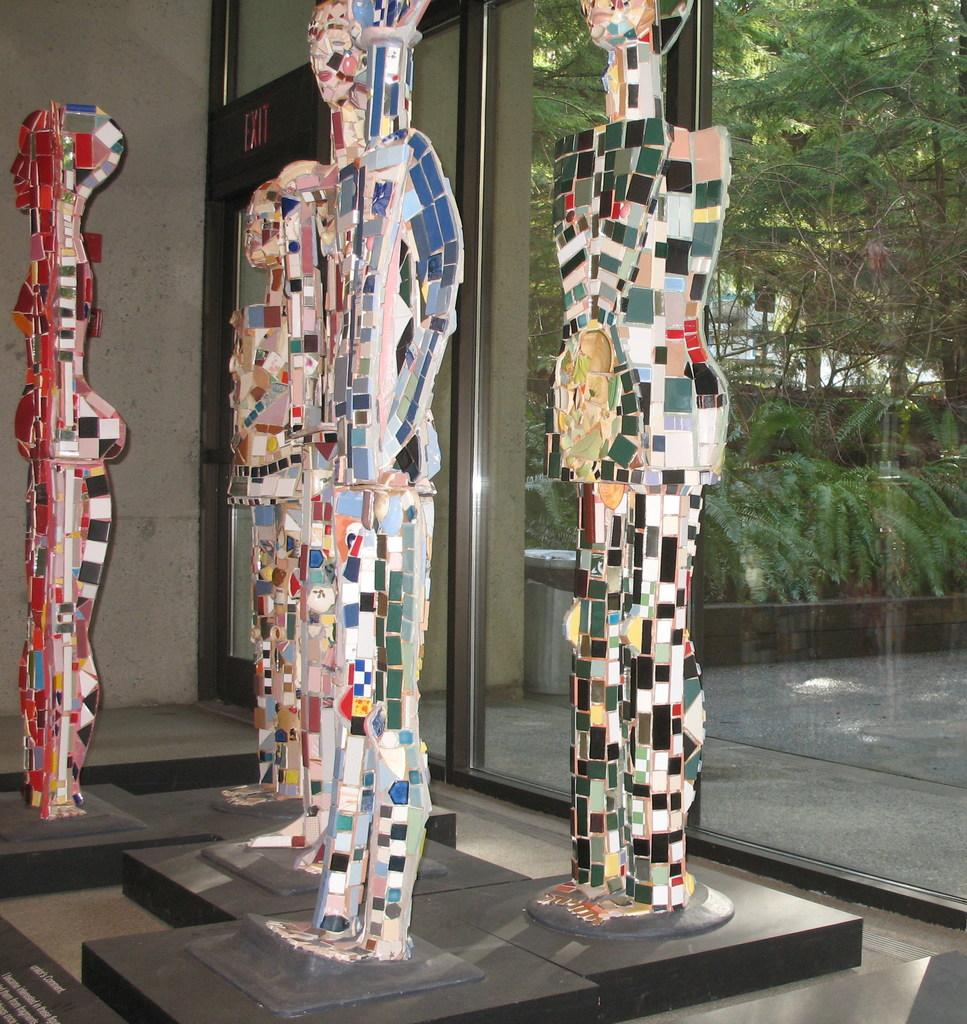How many sculptors are visible in the front of the image? There are five sculptors in the front of the image. What can be seen in the background of the image? There are plants and trees in the background of the image. Where is the exit sign board located in the image? The exit sign board is in the top left side of the image. What color is the nose of the silver sculpture in the image? There is no silver sculpture present in the image, and therefore no nose to describe. 